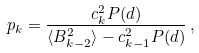Convert formula to latex. <formula><loc_0><loc_0><loc_500><loc_500>p _ { k } = \frac { c _ { k } ^ { 2 } P ( d ) } { \langle B _ { k - 2 } ^ { 2 } \rangle - c _ { k - 1 } ^ { 2 } P ( d ) } \, ,</formula> 